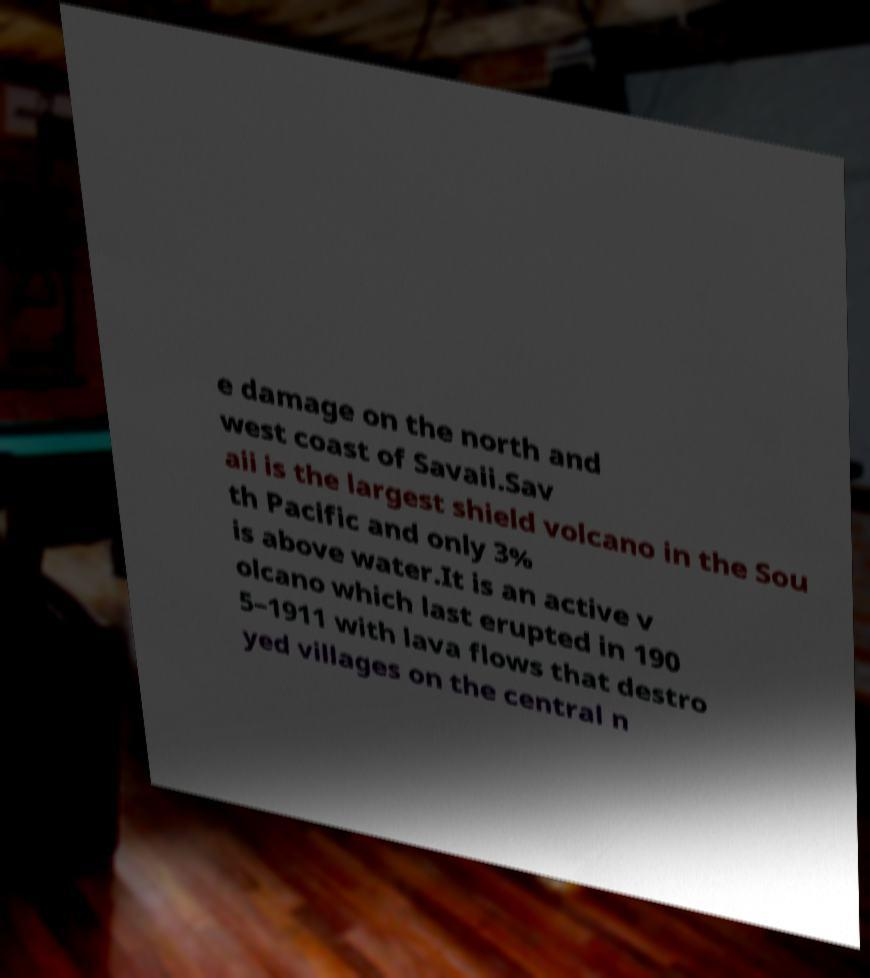Can you accurately transcribe the text from the provided image for me? e damage on the north and west coast of Savaii.Sav aii is the largest shield volcano in the Sou th Pacific and only 3% is above water.It is an active v olcano which last erupted in 190 5–1911 with lava flows that destro yed villages on the central n 